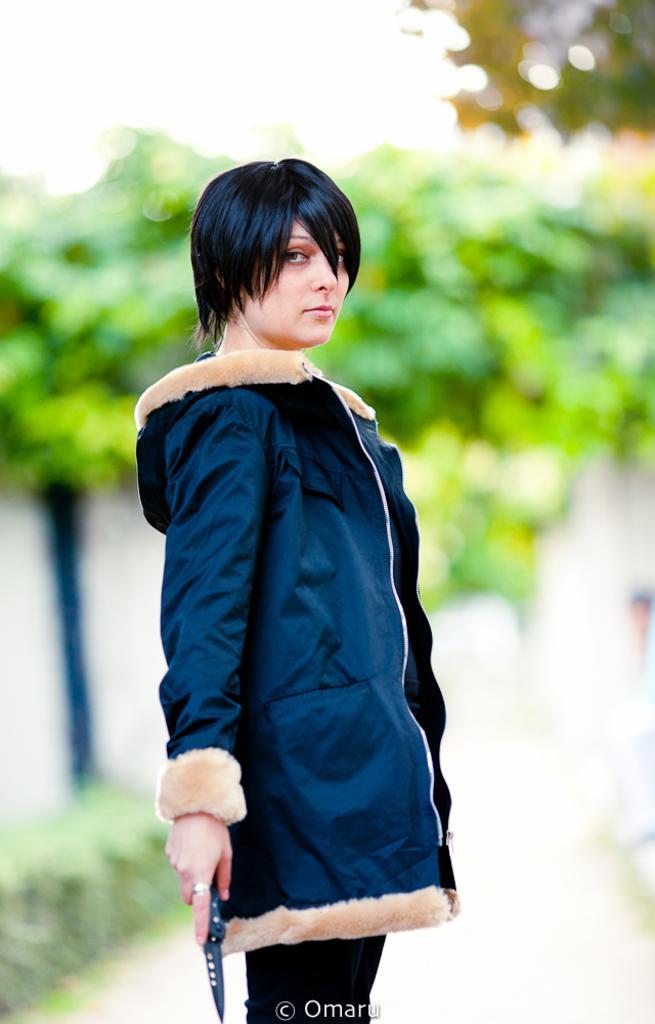Please provide a concise description of this image. In this image we can see a lady and she is holding an object in her hand. There are many trees and plants in the image. There is a pole in the image. 